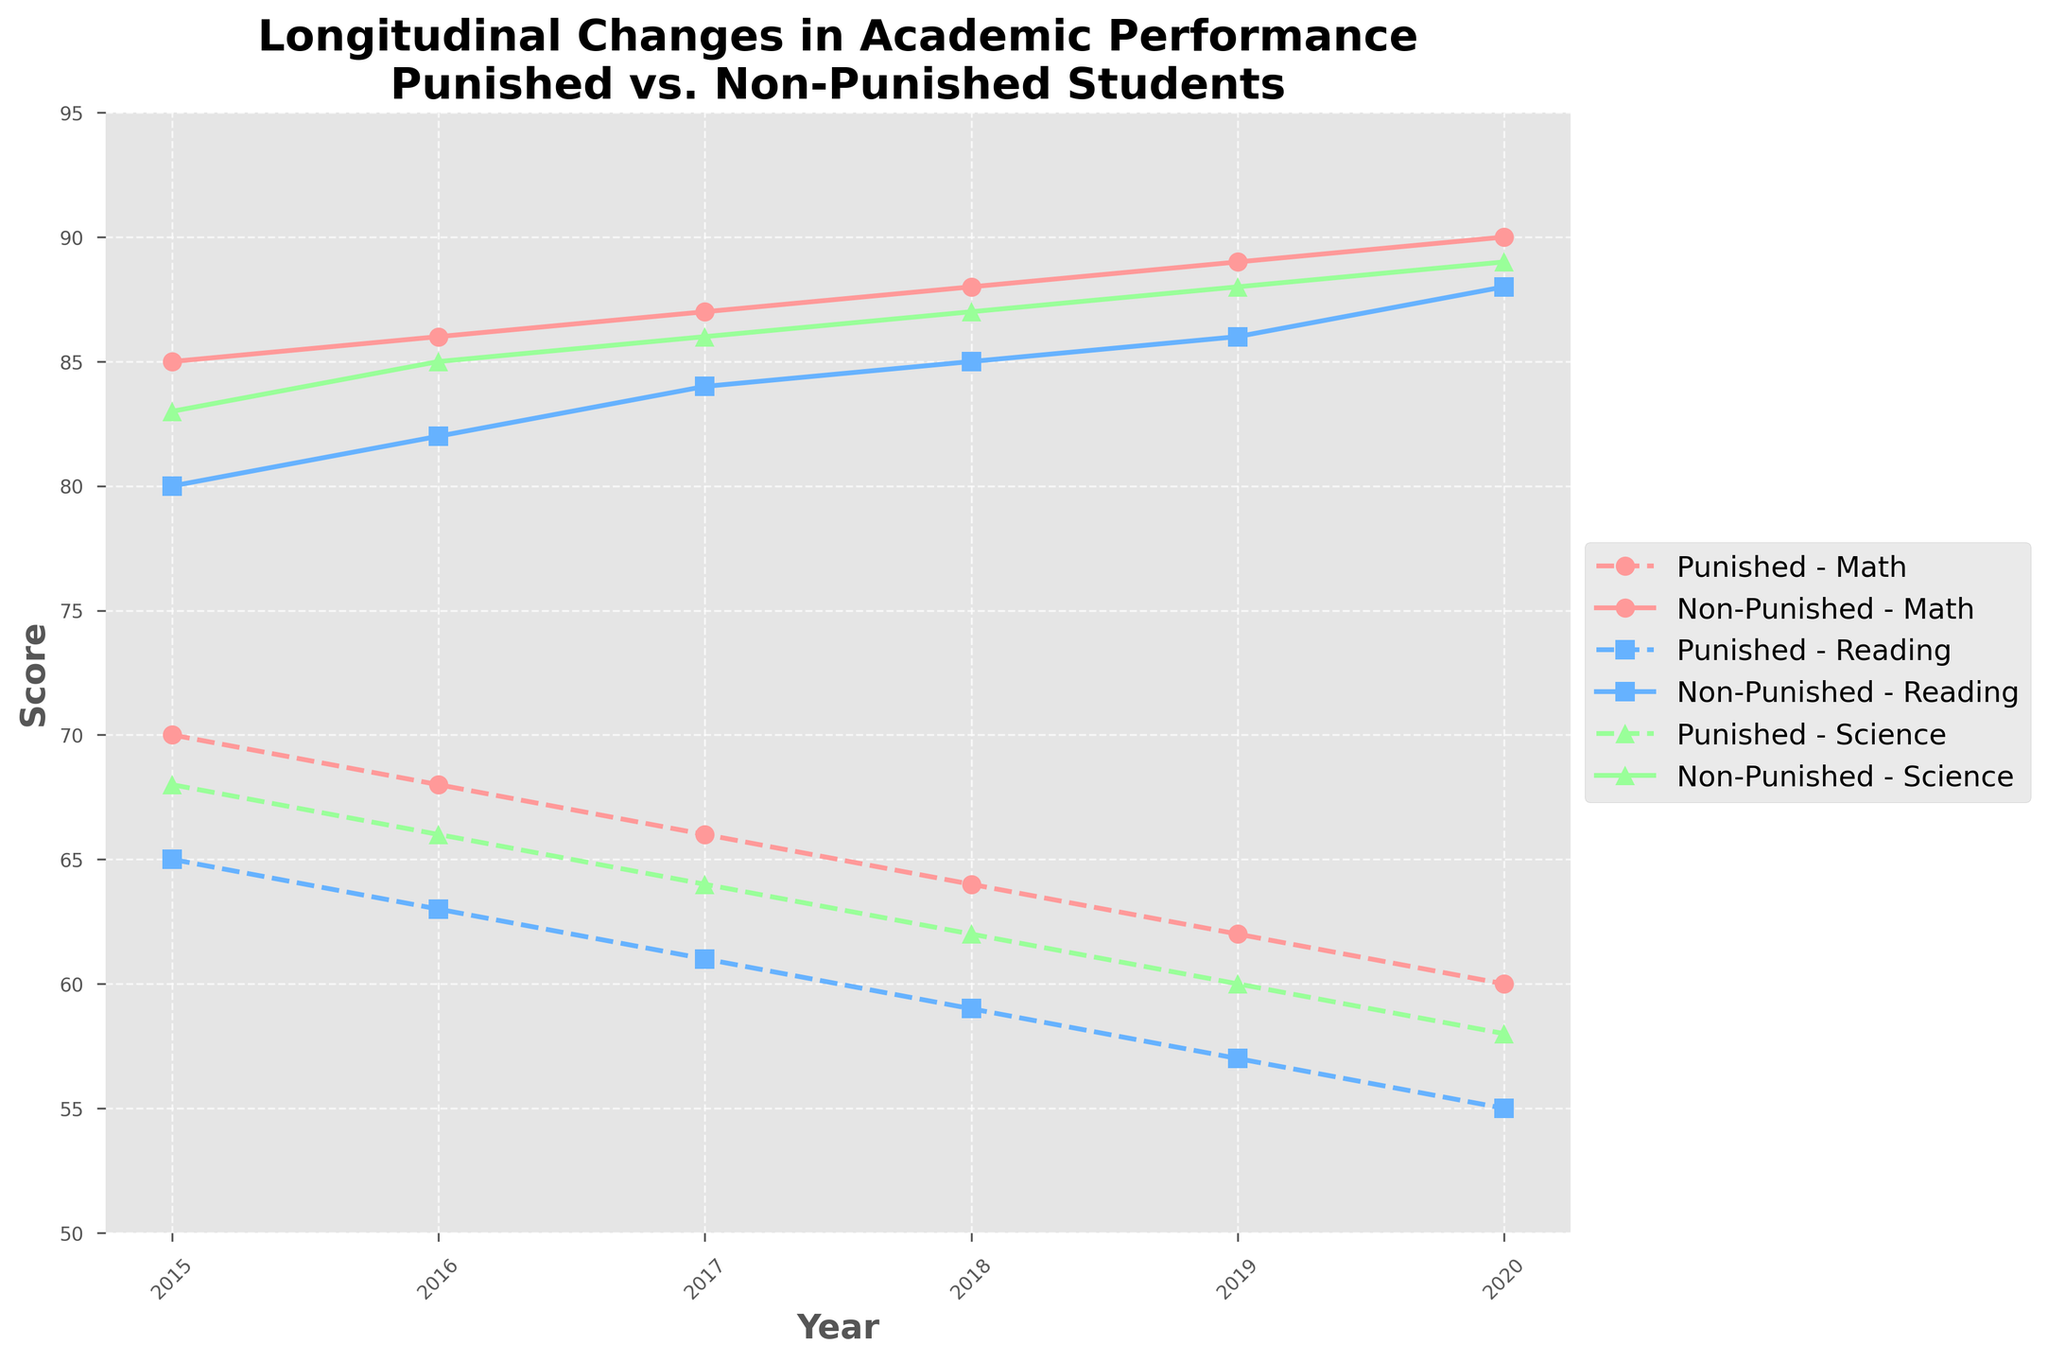What's the title of the plot? The title is prominently shown at the top of the chart.
Answer: Longitudinal Changes in Academic Performance Among Punished vs. Non-Punished Students What time period does the plot cover? The x-axis represents the time period, detailing the years included in the analysis.
Answer: 2015-2020 What colors are used for the line representing Math scores? The colors for Math scores in the legend are mentioned, noting the group differential using consistent visual styles.
Answer: #FF9999 How many different types of scores are tracked for each group? The legend and multiple lines in the figure indicate the different types of scores being tracked.
Answer: 3 types (Math, Reading, Science) What’s the difference in Math scores between punished and non-punished students in 2020? Find the Math scores for both groups in 2020 from the plot, then calculate the difference.
Answer: 30 points Which group shows a decline in Reading scores over the years? By observing the trend lines for the Reading scores, identify which group's scores are decreasing.
Answer: Punished What is the trend in Science scores for non-punished students from 2015 to 2020? By following the Science score line for non-punished students over the years, identify the overall trend.
Answer: Upward trend How much did the Math score for punished students change from 2015 to 2020? Find the Math scores for punished students in 2015 and 2020, then subtract to find the change.
Answer: Decrease of 10 points Which subject showed the smallest difference between punished and non-punished students in 2015? Compare the gaps between punished and non-punished students' scores in Math, Reading, and Science for 2015.
Answer: Reading During which year did punished students have their largest drop in Science scores? Compare year-by-year changes in Science scores for punished students to identify the maximum drop.
Answer: 2019 